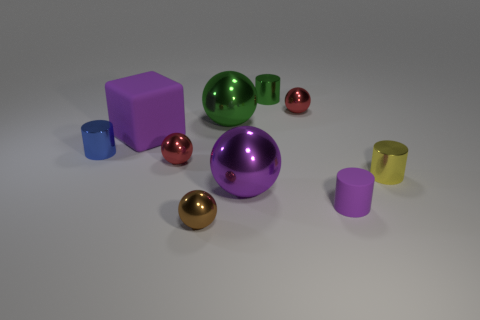Subtract all green balls. How many balls are left? 4 Subtract all big purple spheres. How many spheres are left? 4 Subtract 1 balls. How many balls are left? 4 Subtract all cyan spheres. Subtract all purple cylinders. How many spheres are left? 5 Subtract all cylinders. How many objects are left? 6 Add 2 purple rubber cubes. How many purple rubber cubes exist? 3 Subtract 0 cyan blocks. How many objects are left? 10 Subtract all yellow shiny balls. Subtract all metallic spheres. How many objects are left? 5 Add 1 purple metal spheres. How many purple metal spheres are left? 2 